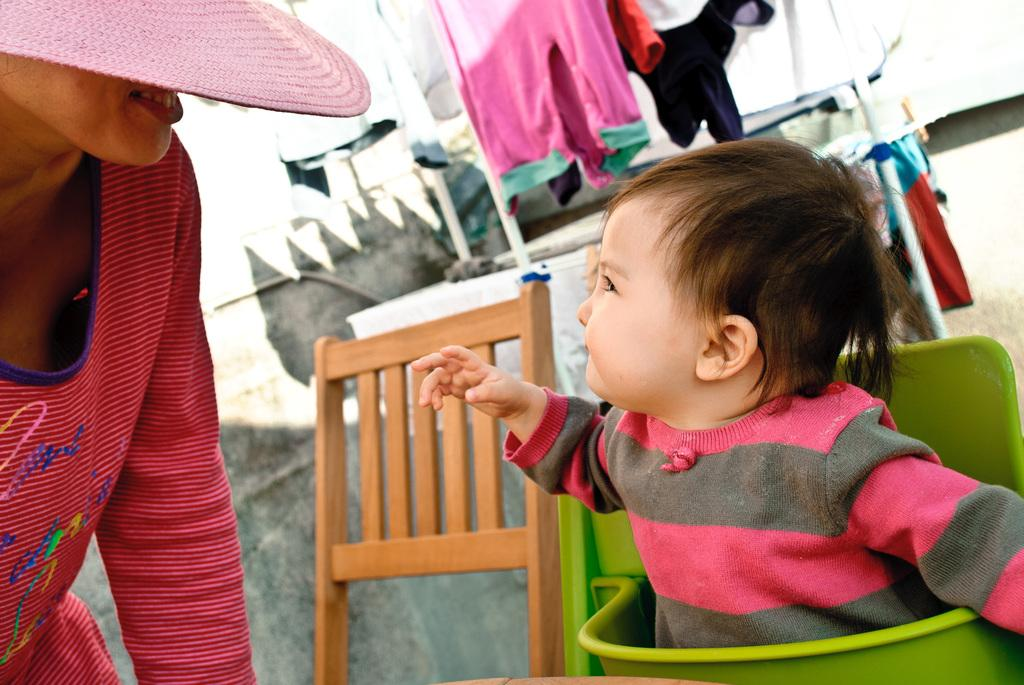What is the main subject of the image? There is a kid in the image. What object is present in the image that the kid might use? There is a chair in the image. Can you describe another person in the image? There is a person in the image. What can be seen in the background of the image? Clothes are visible in the background of the image. What type of squirrel can be seen writing a letter in the image? There is no squirrel or writing activity present in the image. 